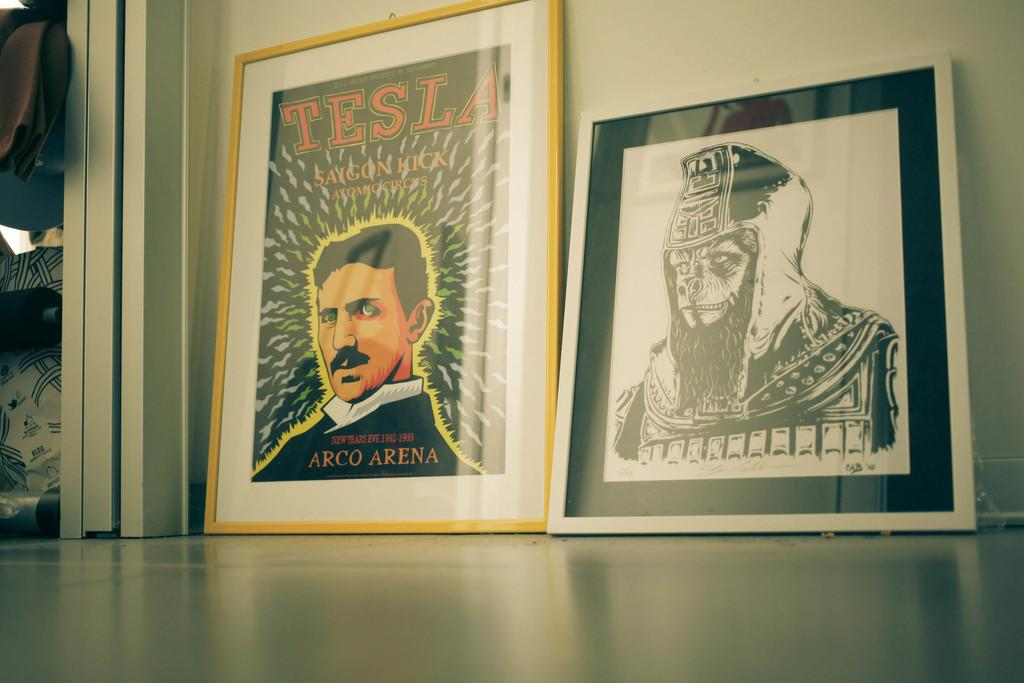<image>
Render a clear and concise summary of the photo. Two picture against a wall one of which has a man's face on it with "Tesla" above him 